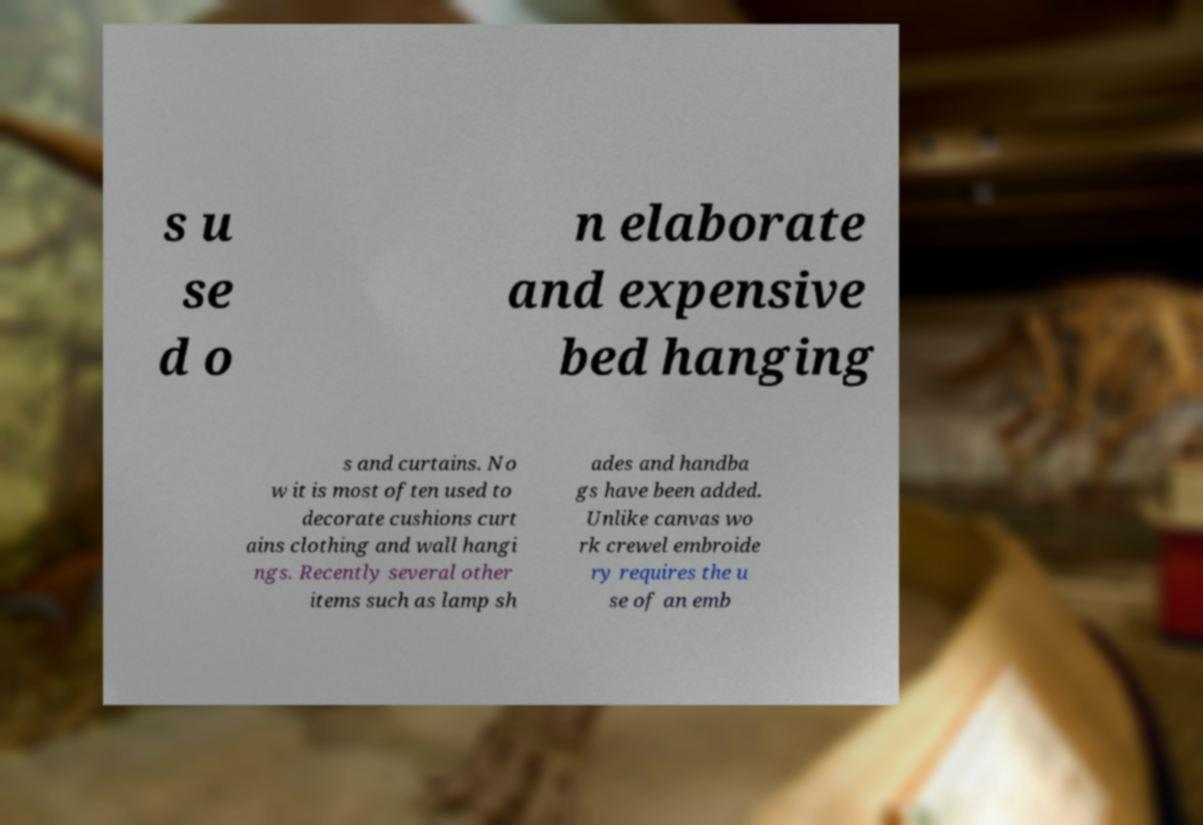I need the written content from this picture converted into text. Can you do that? s u se d o n elaborate and expensive bed hanging s and curtains. No w it is most often used to decorate cushions curt ains clothing and wall hangi ngs. Recently several other items such as lamp sh ades and handba gs have been added. Unlike canvas wo rk crewel embroide ry requires the u se of an emb 